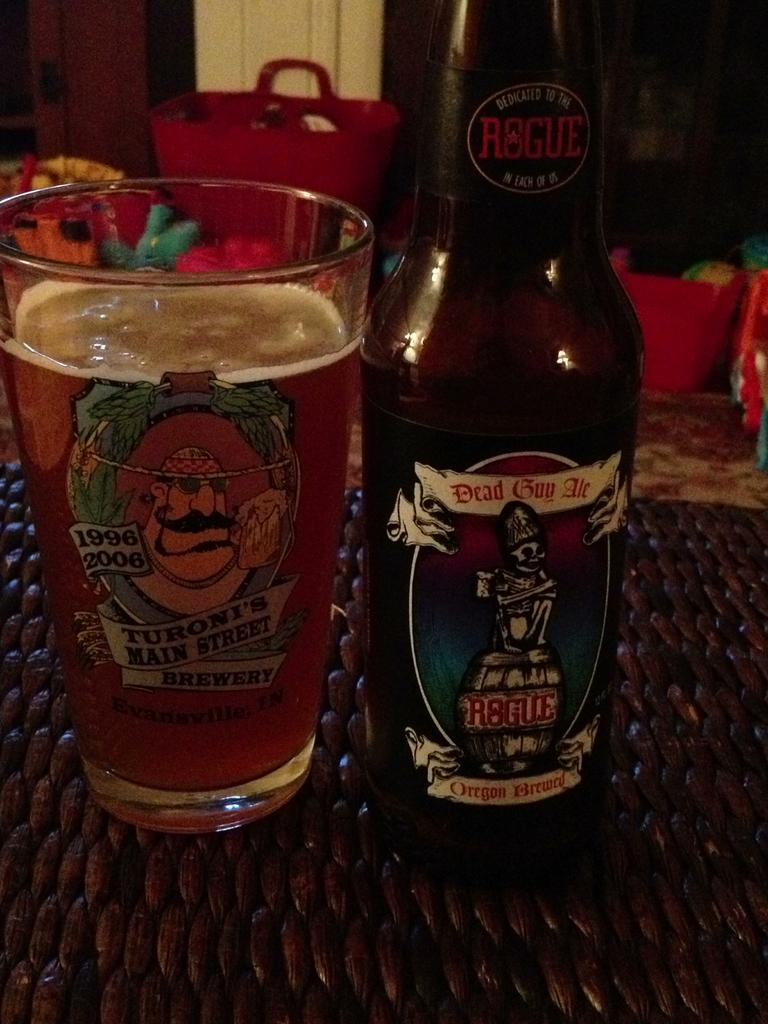<image>
Describe the image concisely. A bottle of Dead guy Ale is next to a drinking glass full of beer. 